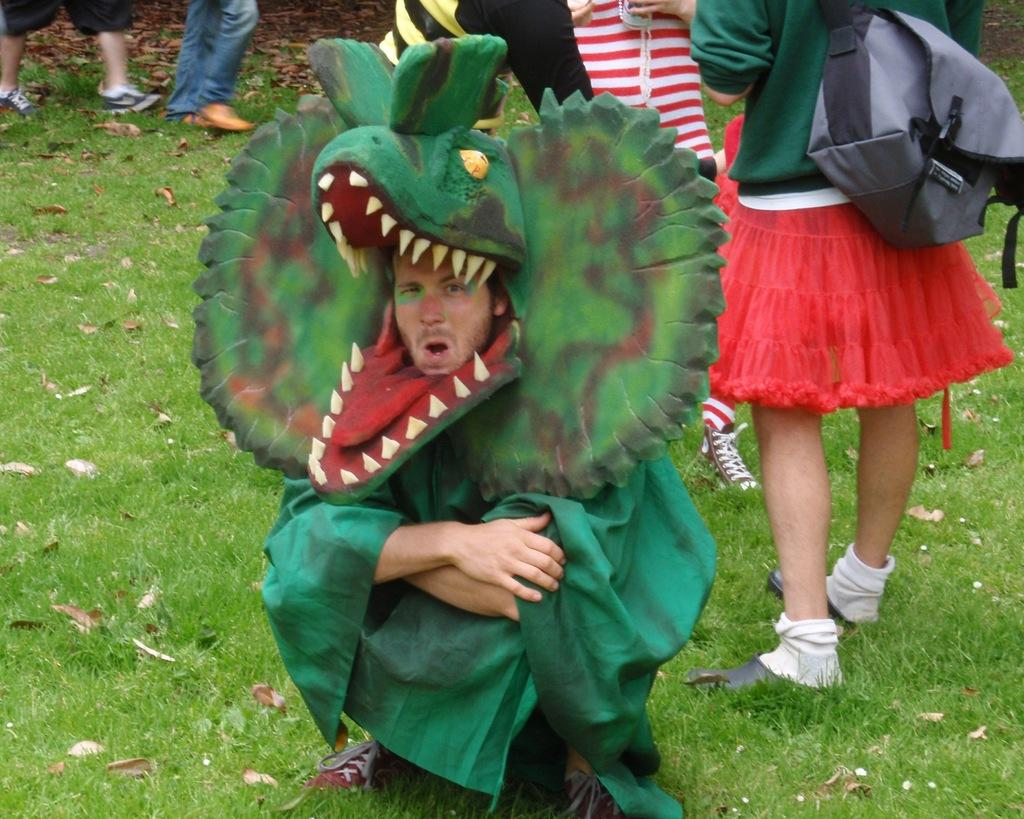What is the main subject in the center of the image? There is a person wearing a costume in the center of the image. What can be seen in the background of the image? There are people standing in the background. What type of surface is at the bottom of the image? There is grass at the bottom of the image. What type of meat is being served in the jail cell in the image? There is no jail or meat present in the image; it features a person wearing a costume and people standing in the background. 